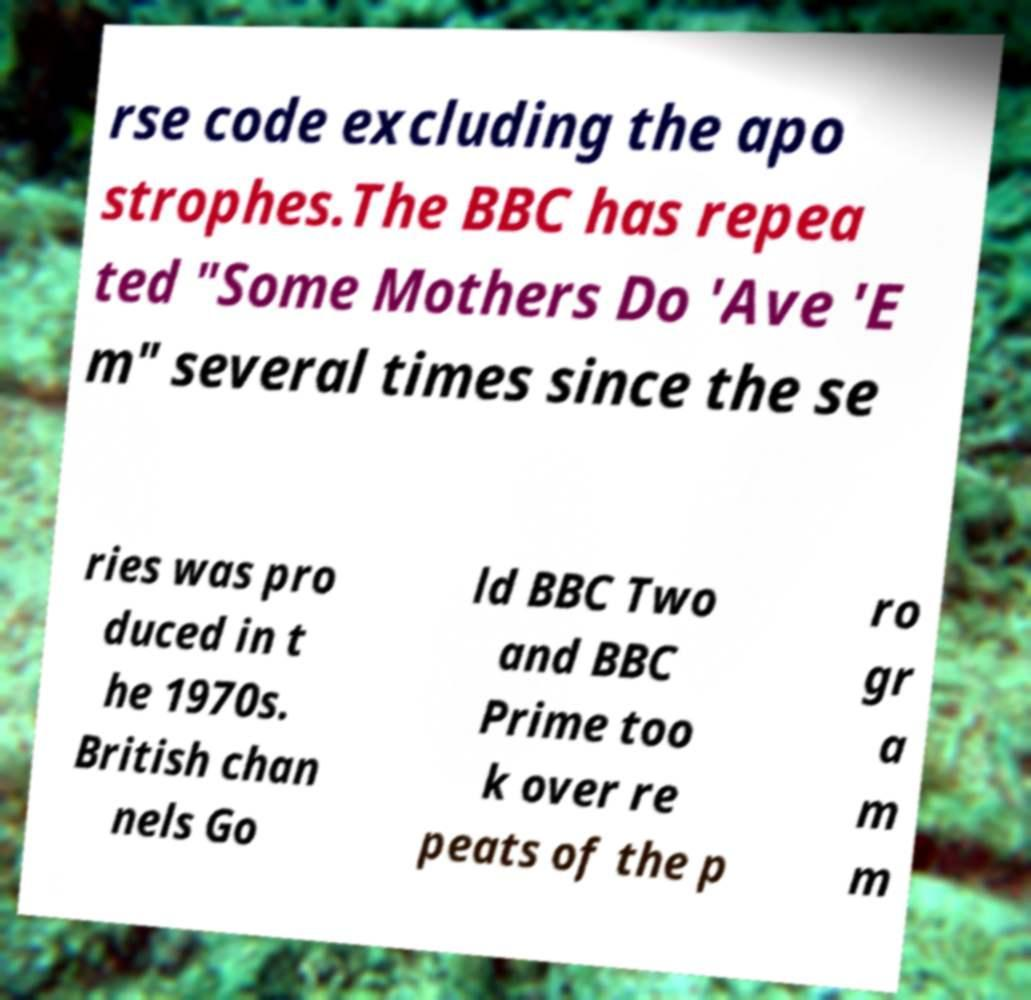Could you extract and type out the text from this image? rse code excluding the apo strophes.The BBC has repea ted "Some Mothers Do 'Ave 'E m" several times since the se ries was pro duced in t he 1970s. British chan nels Go ld BBC Two and BBC Prime too k over re peats of the p ro gr a m m 